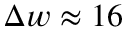Convert formula to latex. <formula><loc_0><loc_0><loc_500><loc_500>\Delta w \approx 1 6</formula> 